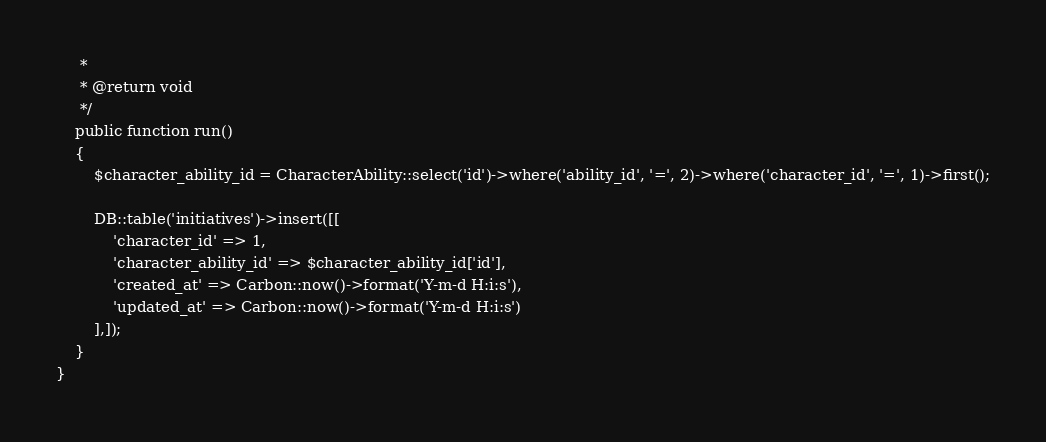<code> <loc_0><loc_0><loc_500><loc_500><_PHP_>     *
     * @return void
     */
    public function run()
    {
        $character_ability_id = CharacterAbility::select('id')->where('ability_id', '=', 2)->where('character_id', '=', 1)->first();

        DB::table('initiatives')->insert([[
            'character_id' => 1,
            'character_ability_id' => $character_ability_id['id'],
            'created_at' => Carbon::now()->format('Y-m-d H:i:s'),
            'updated_at' => Carbon::now()->format('Y-m-d H:i:s')
        ],]);
    }
}
</code> 